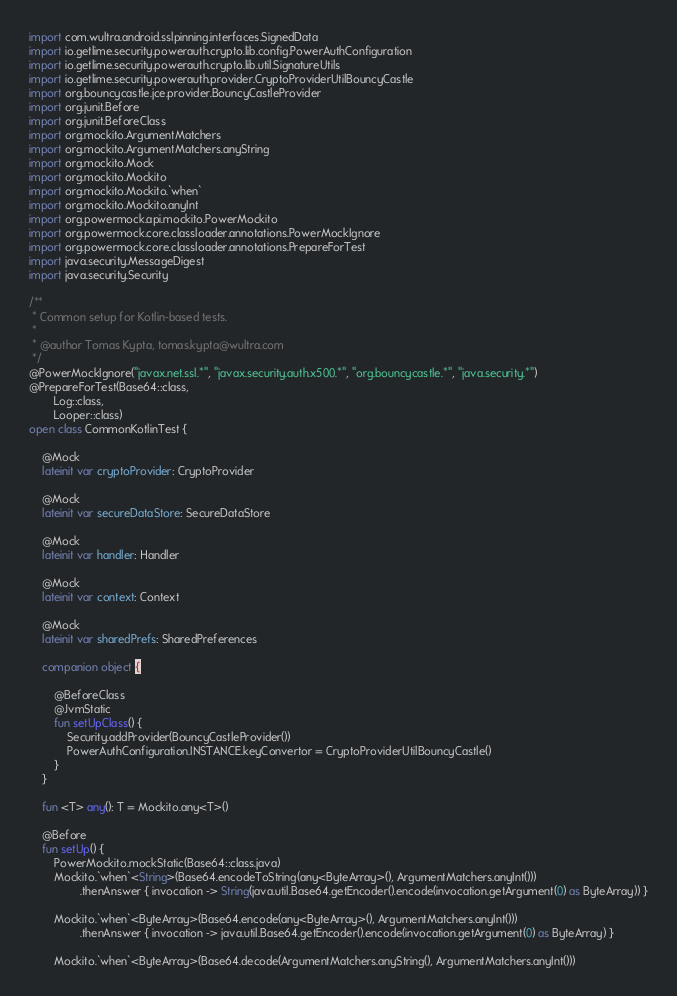Convert code to text. <code><loc_0><loc_0><loc_500><loc_500><_Kotlin_>import com.wultra.android.sslpinning.interfaces.SignedData
import io.getlime.security.powerauth.crypto.lib.config.PowerAuthConfiguration
import io.getlime.security.powerauth.crypto.lib.util.SignatureUtils
import io.getlime.security.powerauth.provider.CryptoProviderUtilBouncyCastle
import org.bouncycastle.jce.provider.BouncyCastleProvider
import org.junit.Before
import org.junit.BeforeClass
import org.mockito.ArgumentMatchers
import org.mockito.ArgumentMatchers.anyString
import org.mockito.Mock
import org.mockito.Mockito
import org.mockito.Mockito.`when`
import org.mockito.Mockito.anyInt
import org.powermock.api.mockito.PowerMockito
import org.powermock.core.classloader.annotations.PowerMockIgnore
import org.powermock.core.classloader.annotations.PrepareForTest
import java.security.MessageDigest
import java.security.Security

/**
 * Common setup for Kotlin-based tests.
 *
 * @author Tomas Kypta, tomas.kypta@wultra.com
 */
@PowerMockIgnore("javax.net.ssl.*", "javax.security.auth.x500.*", "org.bouncycastle.*", "java.security.*")
@PrepareForTest(Base64::class,
        Log::class,
        Looper::class)
open class CommonKotlinTest {

    @Mock
    lateinit var cryptoProvider: CryptoProvider

    @Mock
    lateinit var secureDataStore: SecureDataStore

    @Mock
    lateinit var handler: Handler

    @Mock
    lateinit var context: Context

    @Mock
    lateinit var sharedPrefs: SharedPreferences

    companion object {

        @BeforeClass
        @JvmStatic
        fun setUpClass() {
            Security.addProvider(BouncyCastleProvider())
            PowerAuthConfiguration.INSTANCE.keyConvertor = CryptoProviderUtilBouncyCastle()
        }
    }

    fun <T> any(): T = Mockito.any<T>()

    @Before
    fun setUp() {
        PowerMockito.mockStatic(Base64::class.java)
        Mockito.`when`<String>(Base64.encodeToString(any<ByteArray>(), ArgumentMatchers.anyInt()))
                .thenAnswer { invocation -> String(java.util.Base64.getEncoder().encode(invocation.getArgument(0) as ByteArray)) }

        Mockito.`when`<ByteArray>(Base64.encode(any<ByteArray>(), ArgumentMatchers.anyInt()))
                .thenAnswer { invocation -> java.util.Base64.getEncoder().encode(invocation.getArgument(0) as ByteArray) }

        Mockito.`when`<ByteArray>(Base64.decode(ArgumentMatchers.anyString(), ArgumentMatchers.anyInt()))</code> 